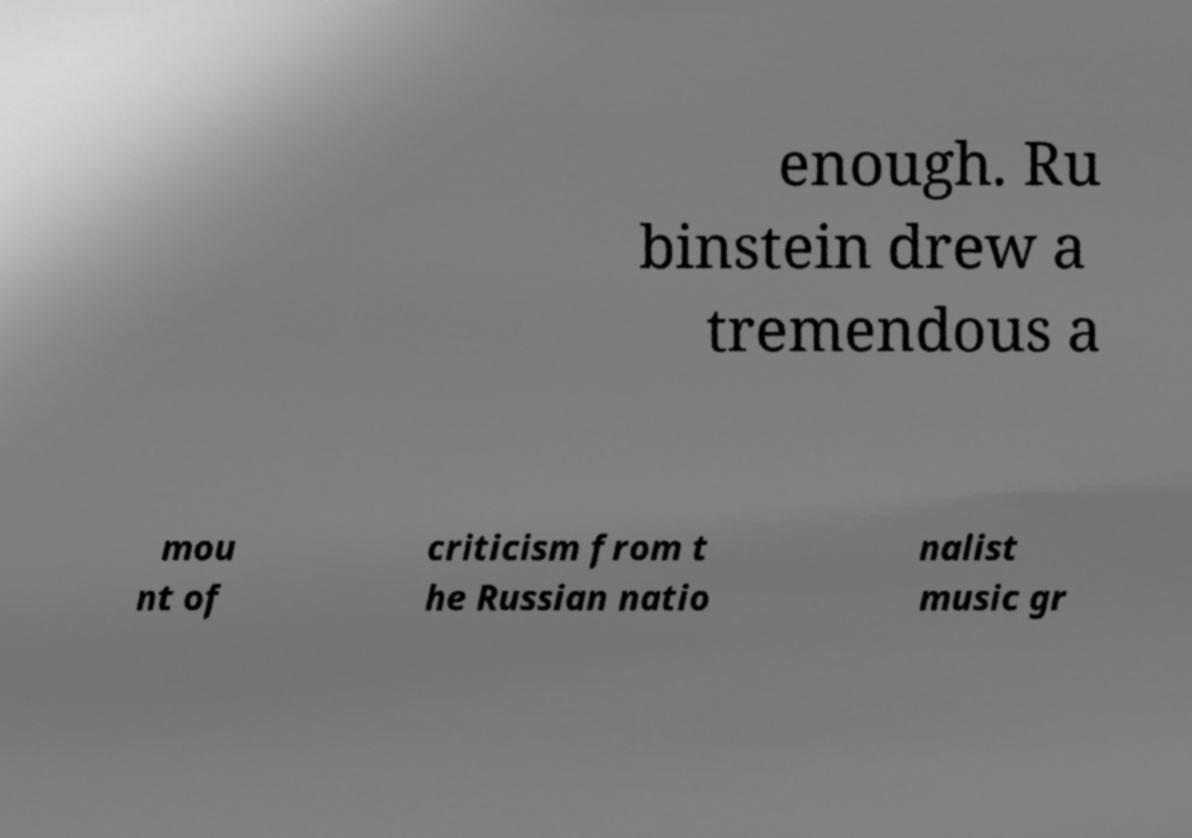I need the written content from this picture converted into text. Can you do that? enough. Ru binstein drew a tremendous a mou nt of criticism from t he Russian natio nalist music gr 